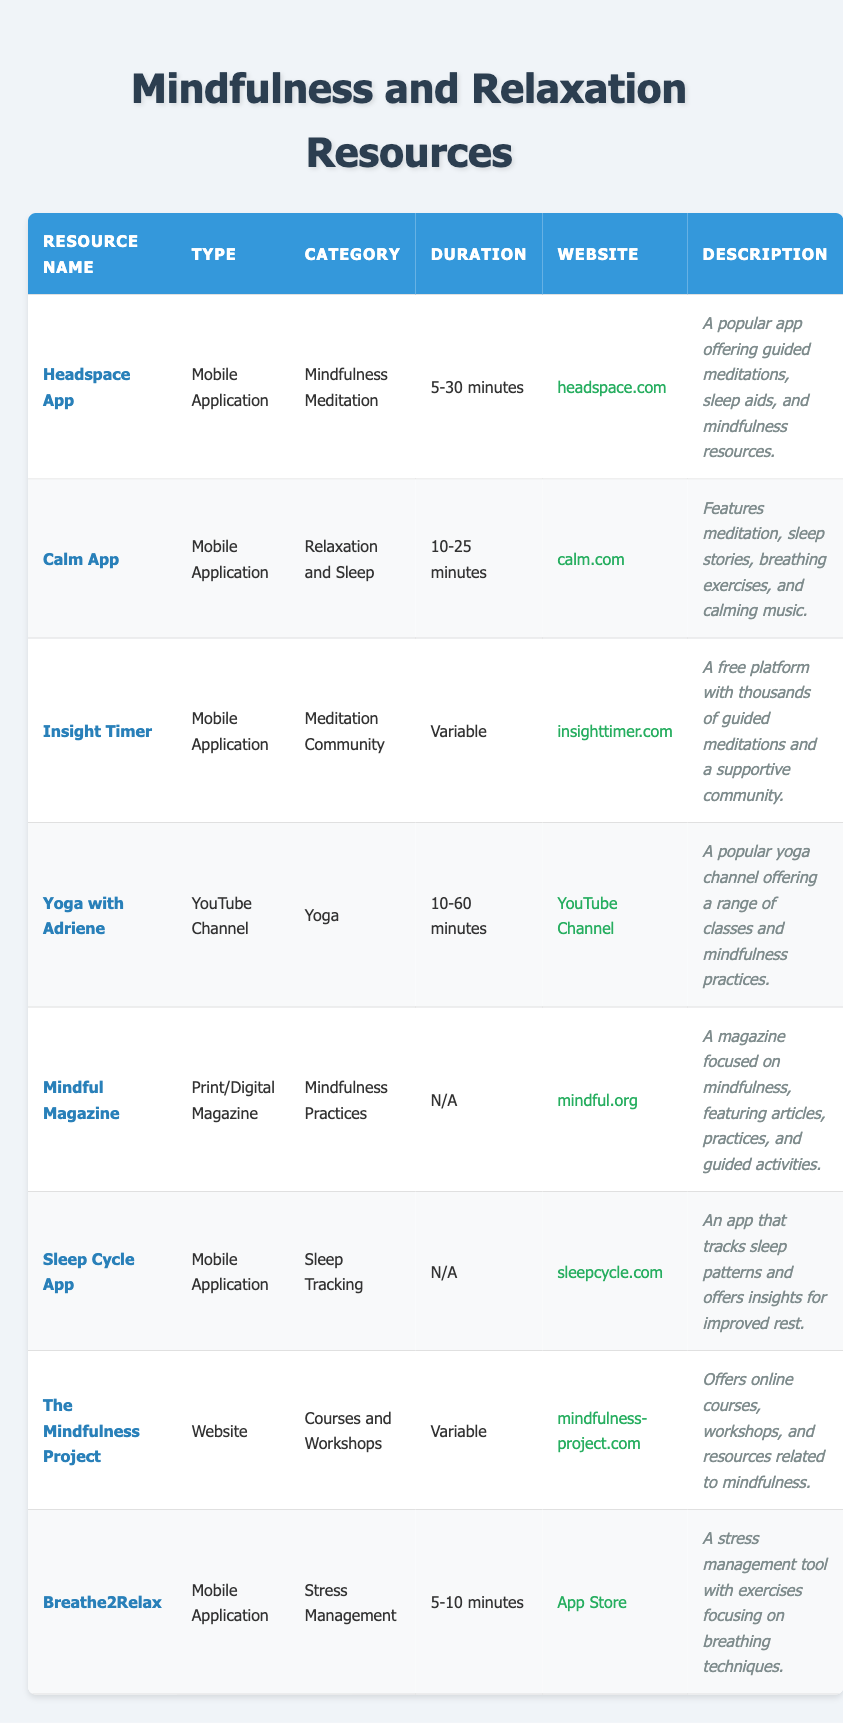What is the duration range of the Calm App? The Calm App has a listed duration of "10-25 minutes," which can be found in the table under the Duration column for that specific resource.
Answer: 10-25 minutes Is the Headspace App focused on relaxation or mindfulness? The Headspace App falls under the "Mindfulness Meditation" category in the table, which indicates that it is primarily focused on mindfulness rather than relaxation.
Answer: Mindfulness How many resources have a duration of 5-10 minutes? In the table, there are two resources with a duration listed as "5-10 minutes": Breathe2Relax and Headspace App.
Answer: 2 Which resource has a variable duration? The resources with variable durations according to the table are "Insight Timer" and "The Mindfulness Project."
Answer: Insight Timer and The Mindfulness Project Are there any print or digital magazines listed in the inventory? Yes, there is a resource listed in the table called "Mindful Magazine," which is categorized as a Print/Digital Magazine, confirming that there are indeed print or digital magazines in the inventory.
Answer: Yes What is the average duration of the resources listed that have a specified duration? The specified durations provided are: 5-30, 10-25, 5-10, 10-60. Calculating the average involves finding the midpoint of each range (17.5, 17.5, 7.5, 35), summing these values (17.5 + 17.5 + 7.5 + 35 = 77.5) and dividing by 4, which gives an average of approximately 19.375 minutes.
Answer: Approximately 19.375 minutes Does the Sleep Cycle App offer resources related to mindfulness practices? The Sleep Cycle App is categorized under "Sleep Tracking," which does not fall under the mindfulness practices category as indicated in the table. Thus, it does not offer resources related to mindfulness.
Answer: No Which app focuses specifically on stress management and what is its duration? The app that focuses specifically on stress management is "Breathe2Relax," and it has a specified duration of "5-10 minutes" according to the table.
Answer: Breathe2Relax; 5-10 minutes Based on the table, can you find a link to a resource that offers online courses? Yes, "The Mindfulness Project" is the resource linked to online courses and workshops, and the website can be found in the table.
Answer: Yes, The Mindfulness Project 